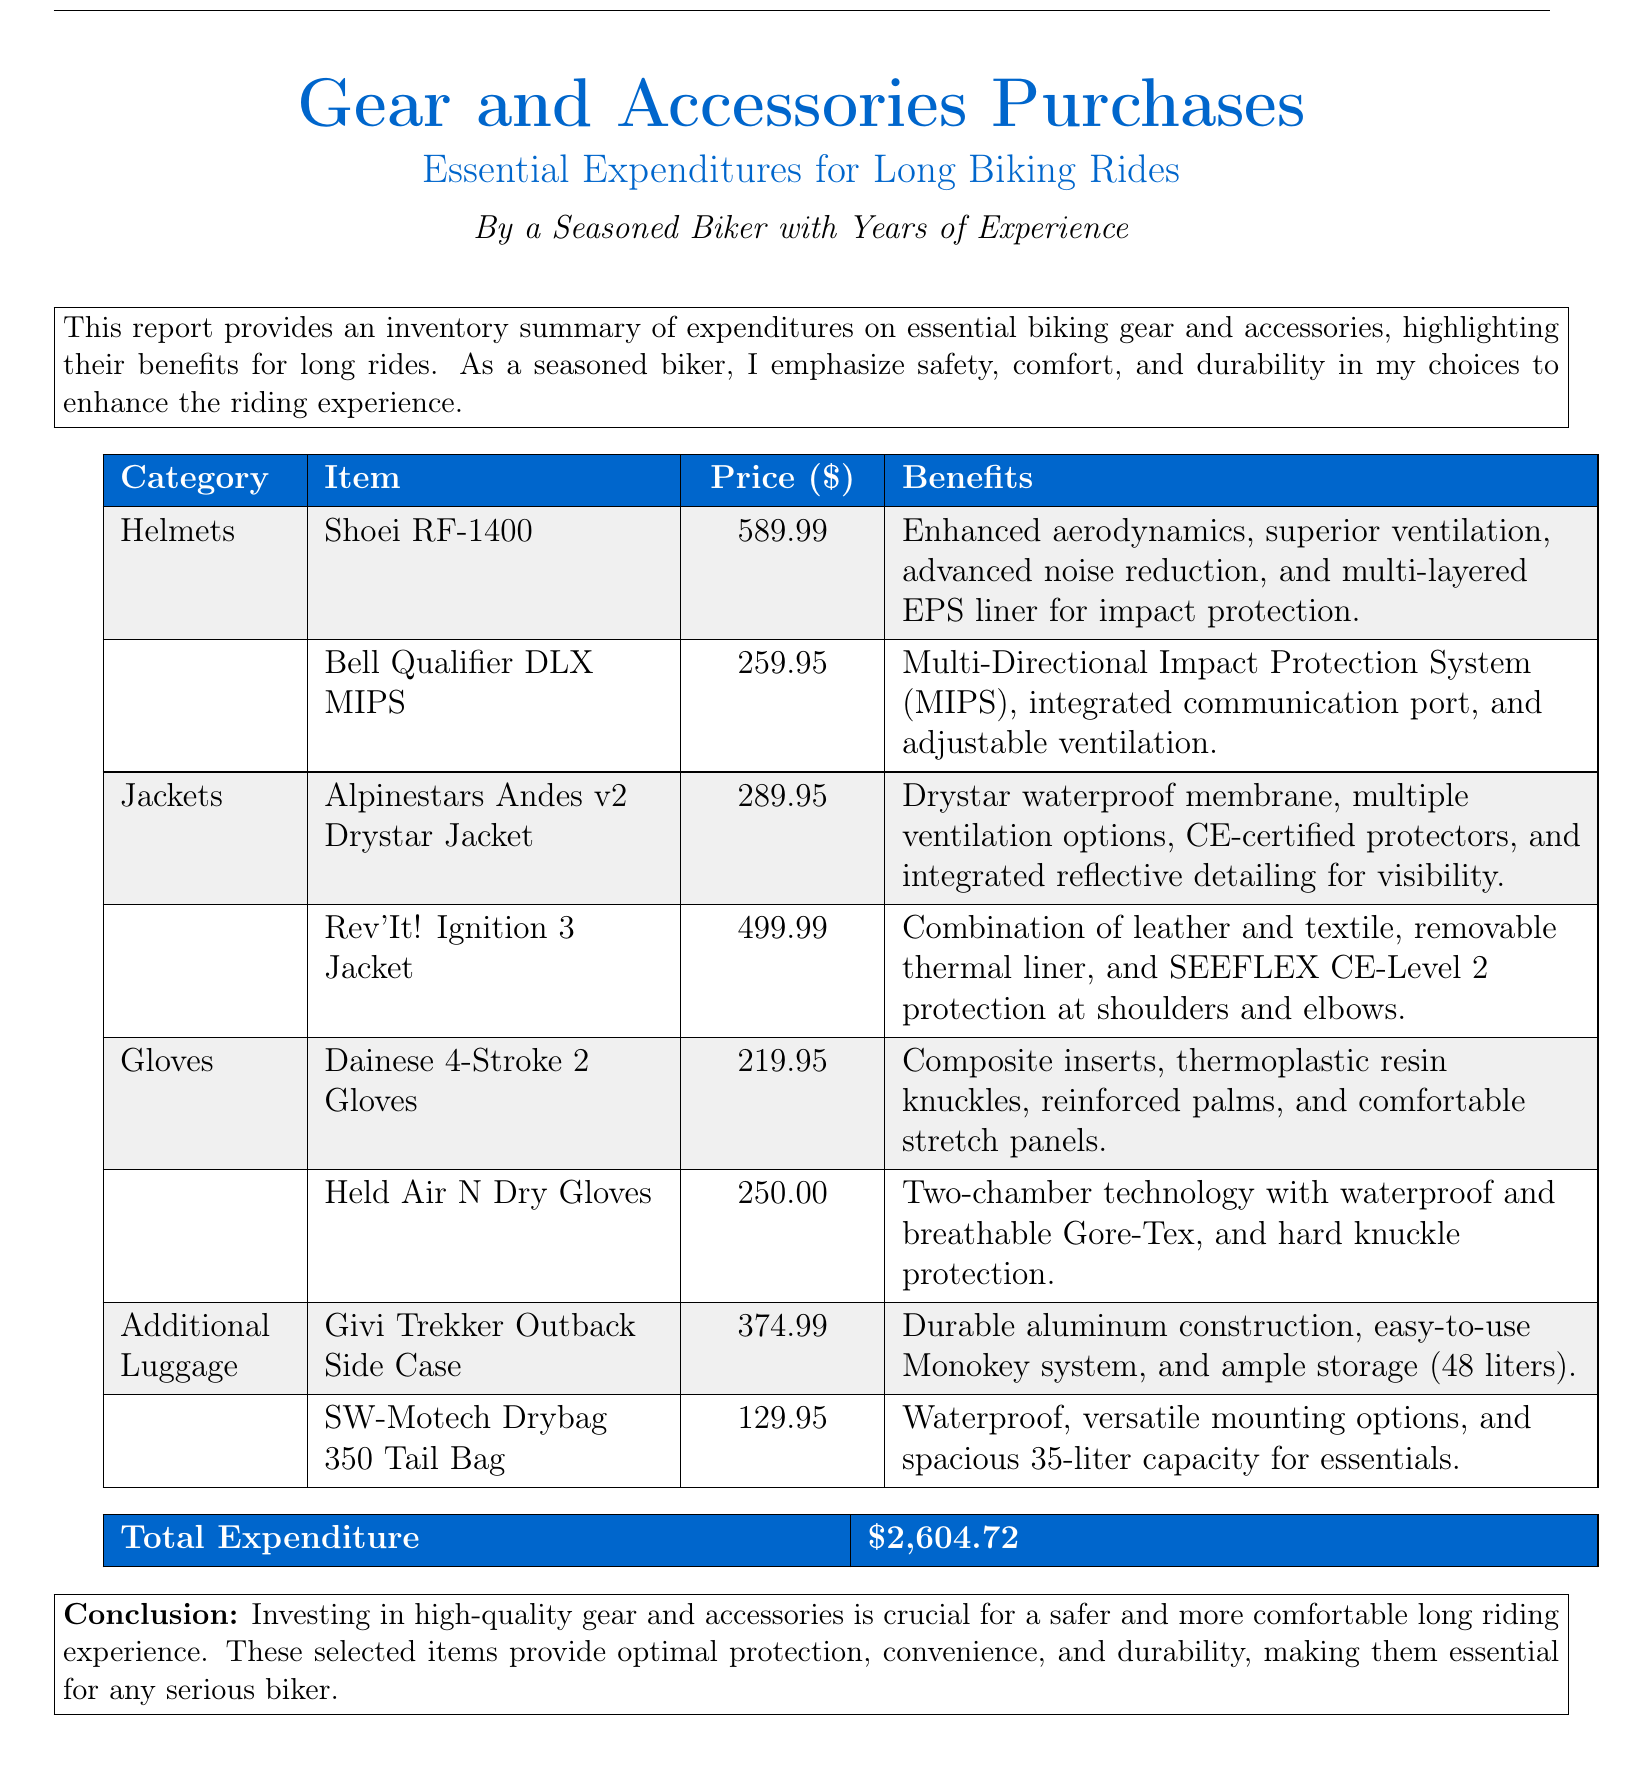What is the total expenditure? The total expenditure is stated at the end of the report, summing all purchases made on gear and accessories.
Answer: $2,604.72 What is the price of the Shoei RF-1400 helmet? The price of the Shoei RF-1400 helmet is listed in the inventory summary of the helmets category.
Answer: $589.99 What feature does the Bell Qualifier DLX MIPS helmet provide? The benefits for each item include specific features, with the Bell Qualifier DLX MIPS helmet offering MIPS protection.
Answer: Multi-Directional Impact Protection System (MIPS) What type of membrane does the Alpinestars Andes v2 jacket have? The benefits section specifies the type of membrane for the Alpinestars Andes v2 jacket as part of its waterproof capability.
Answer: Drystar waterproof membrane How many liters can the Givi Trekker Outback Side Case hold? The benefits of the Givi Trekker Outback Side Case mention its storage capacity in liters.
Answer: 48 liters Which glove has hard knuckle protection? The benefits section describes the features of each glove, indicating which has hard knuckle protection.
Answer: Held Air N Dry Gloves What is the price of the SW-Motech Drybag 350 Tail Bag? The inventory summary provides specific prices for additional luggage items, including the SW-Motech Drybag.
Answer: $129.95 Which jacket combines leather and textile? The benefits highlight the material composition of each jacket, specifically mentioning the combination for one jacket.
Answer: Rev'It! Ignition 3 Jacket What are the benefits of investing in high-quality gear? The conclusion summarizes the advantages of quality gear for biking, stating the overall benefits found throughout the report.
Answer: Optimal protection, convenience, and durability 